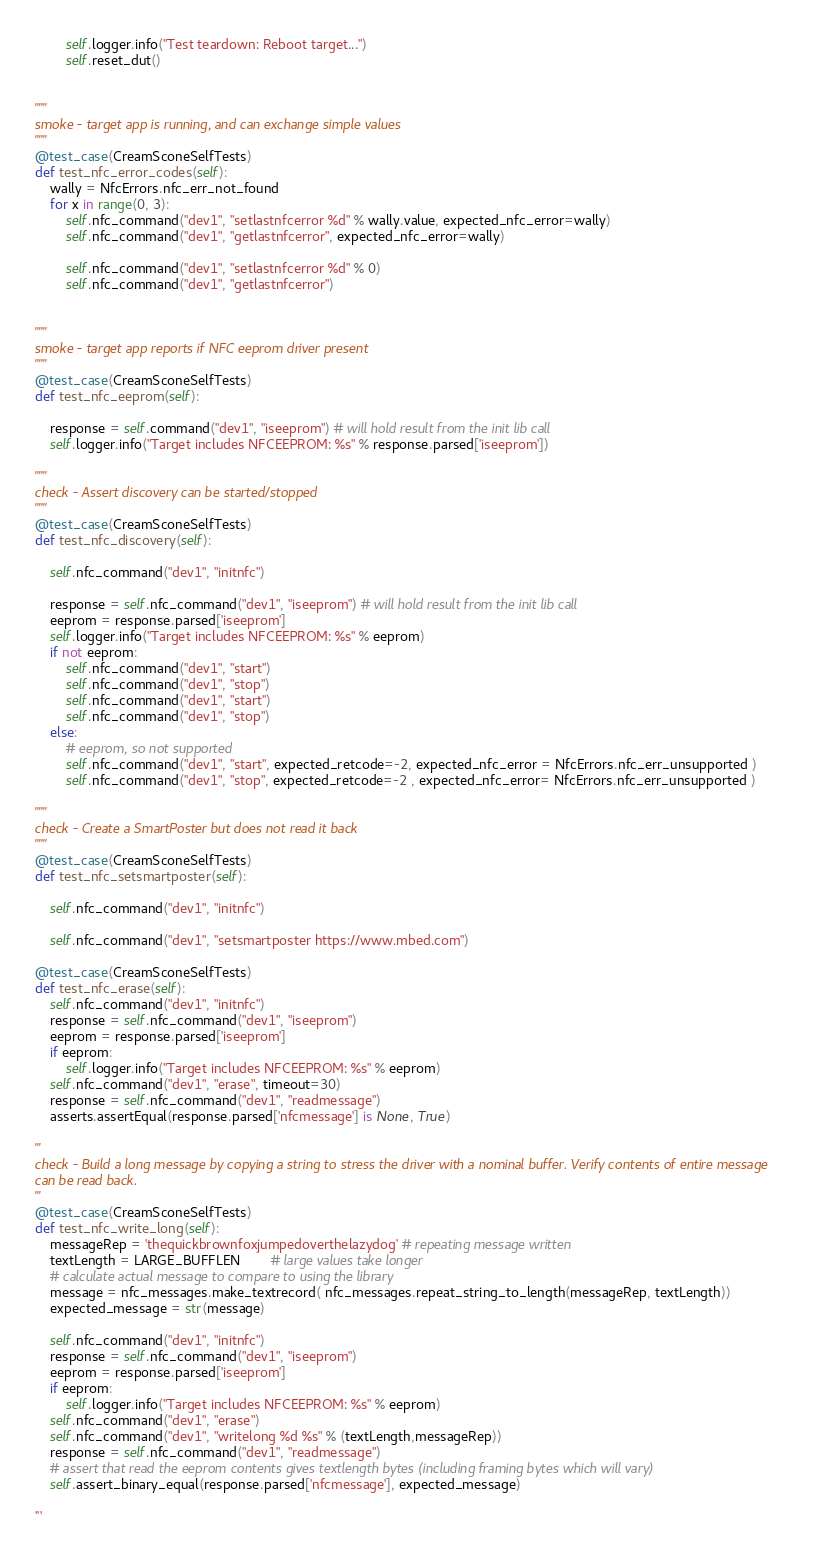Convert code to text. <code><loc_0><loc_0><loc_500><loc_500><_Python_>        self.logger.info("Test teardown: Reboot target...")
        self.reset_dut()


"""
smoke - target app is running, and can exchange simple values
"""
@test_case(CreamSconeSelfTests)
def test_nfc_error_codes(self):
    wally = NfcErrors.nfc_err_not_found
    for x in range(0, 3):
        self.nfc_command("dev1", "setlastnfcerror %d" % wally.value, expected_nfc_error=wally)
        self.nfc_command("dev1", "getlastnfcerror", expected_nfc_error=wally)

        self.nfc_command("dev1", "setlastnfcerror %d" % 0)
        self.nfc_command("dev1", "getlastnfcerror")


"""
smoke - target app reports if NFC eeprom driver present
"""
@test_case(CreamSconeSelfTests)
def test_nfc_eeprom(self):

    response = self.command("dev1", "iseeprom") # will hold result from the init lib call
    self.logger.info("Target includes NFCEEPROM: %s" % response.parsed['iseeprom'])

"""
check - Assert discovery can be started/stopped
"""
@test_case(CreamSconeSelfTests)
def test_nfc_discovery(self):

    self.nfc_command("dev1", "initnfc")

    response = self.nfc_command("dev1", "iseeprom") # will hold result from the init lib call
    eeprom = response.parsed['iseeprom']
    self.logger.info("Target includes NFCEEPROM: %s" % eeprom)
    if not eeprom:
        self.nfc_command("dev1", "start")
        self.nfc_command("dev1", "stop")
        self.nfc_command("dev1", "start")
        self.nfc_command("dev1", "stop")
    else:
        # eeprom, so not supported
        self.nfc_command("dev1", "start", expected_retcode=-2, expected_nfc_error = NfcErrors.nfc_err_unsupported )
        self.nfc_command("dev1", "stop", expected_retcode=-2 , expected_nfc_error= NfcErrors.nfc_err_unsupported )

"""
check - Create a SmartPoster but does not read it back
"""
@test_case(CreamSconeSelfTests)
def test_nfc_setsmartposter(self):

    self.nfc_command("dev1", "initnfc")

    self.nfc_command("dev1", "setsmartposter https://www.mbed.com")

@test_case(CreamSconeSelfTests)
def test_nfc_erase(self):
    self.nfc_command("dev1", "initnfc")
    response = self.nfc_command("dev1", "iseeprom")
    eeprom = response.parsed['iseeprom']
    if eeprom:
        self.logger.info("Target includes NFCEEPROM: %s" % eeprom)
    self.nfc_command("dev1", "erase", timeout=30)
    response = self.nfc_command("dev1", "readmessage")
    asserts.assertEqual(response.parsed['nfcmessage'] is None, True)

'''
check - Build a long message by copying a string to stress the driver with a nominal buffer. Verify contents of entire message 
can be read back.
'''
@test_case(CreamSconeSelfTests)
def test_nfc_write_long(self):
    messageRep = 'thequickbrownfoxjumpedoverthelazydog' # repeating message written
    textLength = LARGE_BUFFLEN        # large values take longer
    # calculate actual message to compare to using the library
    message = nfc_messages.make_textrecord( nfc_messages.repeat_string_to_length(messageRep, textLength))
    expected_message = str(message)

    self.nfc_command("dev1", "initnfc")
    response = self.nfc_command("dev1", "iseeprom")
    eeprom = response.parsed['iseeprom']
    if eeprom:
        self.logger.info("Target includes NFCEEPROM: %s" % eeprom)
    self.nfc_command("dev1", "erase")
    self.nfc_command("dev1", "writelong %d %s" % (textLength,messageRep))
    response = self.nfc_command("dev1", "readmessage")
    # assert that read the eeprom contents gives textlength bytes (including framing bytes which will vary)
    self.assert_binary_equal(response.parsed['nfcmessage'], expected_message)

'''</code> 